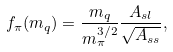Convert formula to latex. <formula><loc_0><loc_0><loc_500><loc_500>f _ { \pi } ( m _ { q } ) = \frac { m _ { q } } { m _ { \pi } ^ { 3 / 2 } } \frac { A _ { s l } } { \sqrt { A _ { s s } } } ,</formula> 